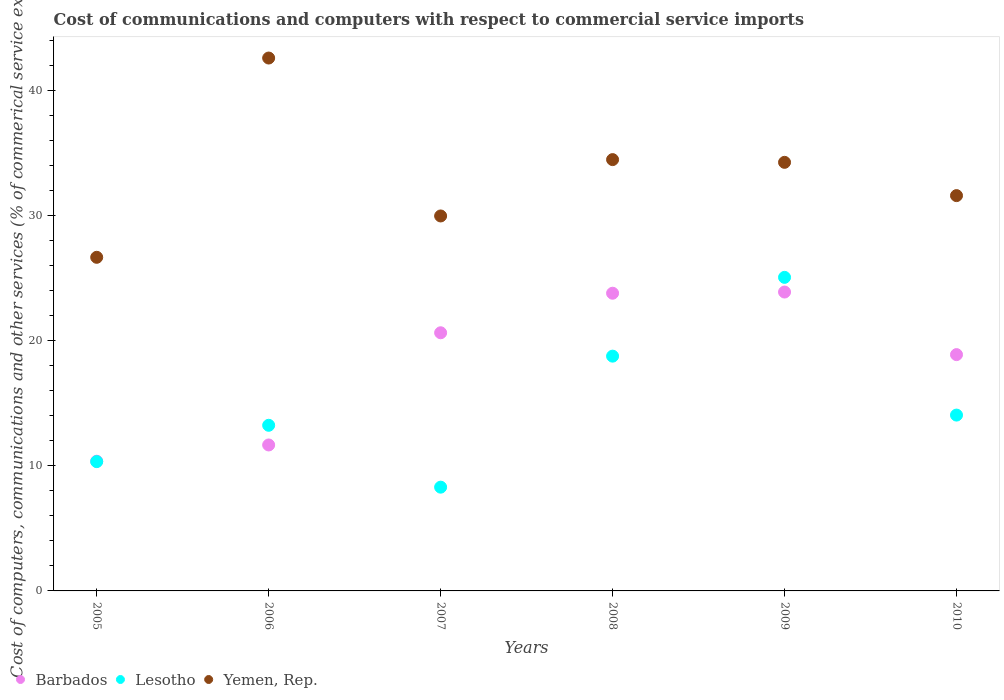Is the number of dotlines equal to the number of legend labels?
Provide a succinct answer. Yes. What is the cost of communications and computers in Yemen, Rep. in 2007?
Offer a very short reply. 29.97. Across all years, what is the maximum cost of communications and computers in Lesotho?
Offer a terse response. 25.06. Across all years, what is the minimum cost of communications and computers in Barbados?
Make the answer very short. 10.37. What is the total cost of communications and computers in Barbados in the graph?
Your answer should be very brief. 109.24. What is the difference between the cost of communications and computers in Yemen, Rep. in 2007 and that in 2008?
Provide a succinct answer. -4.5. What is the difference between the cost of communications and computers in Yemen, Rep. in 2009 and the cost of communications and computers in Barbados in 2008?
Your response must be concise. 10.46. What is the average cost of communications and computers in Lesotho per year?
Ensure brevity in your answer.  14.96. In the year 2009, what is the difference between the cost of communications and computers in Barbados and cost of communications and computers in Lesotho?
Your response must be concise. -1.17. In how many years, is the cost of communications and computers in Yemen, Rep. greater than 18 %?
Ensure brevity in your answer.  6. What is the ratio of the cost of communications and computers in Barbados in 2005 to that in 2010?
Your response must be concise. 0.55. Is the difference between the cost of communications and computers in Barbados in 2009 and 2010 greater than the difference between the cost of communications and computers in Lesotho in 2009 and 2010?
Provide a short and direct response. No. What is the difference between the highest and the second highest cost of communications and computers in Yemen, Rep.?
Provide a succinct answer. 8.12. What is the difference between the highest and the lowest cost of communications and computers in Yemen, Rep.?
Make the answer very short. 15.93. In how many years, is the cost of communications and computers in Barbados greater than the average cost of communications and computers in Barbados taken over all years?
Your answer should be compact. 4. Is the sum of the cost of communications and computers in Barbados in 2007 and 2009 greater than the maximum cost of communications and computers in Yemen, Rep. across all years?
Give a very brief answer. Yes. Is it the case that in every year, the sum of the cost of communications and computers in Yemen, Rep. and cost of communications and computers in Lesotho  is greater than the cost of communications and computers in Barbados?
Offer a terse response. Yes. Is the cost of communications and computers in Barbados strictly greater than the cost of communications and computers in Lesotho over the years?
Make the answer very short. No. How many dotlines are there?
Give a very brief answer. 3. How many years are there in the graph?
Keep it short and to the point. 6. What is the difference between two consecutive major ticks on the Y-axis?
Make the answer very short. 10. Are the values on the major ticks of Y-axis written in scientific E-notation?
Make the answer very short. No. Does the graph contain any zero values?
Your response must be concise. No. Does the graph contain grids?
Provide a succinct answer. No. What is the title of the graph?
Offer a very short reply. Cost of communications and computers with respect to commercial service imports. Does "Faeroe Islands" appear as one of the legend labels in the graph?
Your response must be concise. No. What is the label or title of the X-axis?
Ensure brevity in your answer.  Years. What is the label or title of the Y-axis?
Keep it short and to the point. Cost of computers, communications and other services (% of commerical service exports). What is the Cost of computers, communications and other services (% of commerical service exports) of Barbados in 2005?
Offer a very short reply. 10.37. What is the Cost of computers, communications and other services (% of commerical service exports) of Lesotho in 2005?
Your response must be concise. 10.33. What is the Cost of computers, communications and other services (% of commerical service exports) of Yemen, Rep. in 2005?
Make the answer very short. 26.67. What is the Cost of computers, communications and other services (% of commerical service exports) of Barbados in 2006?
Provide a succinct answer. 11.67. What is the Cost of computers, communications and other services (% of commerical service exports) of Lesotho in 2006?
Give a very brief answer. 13.24. What is the Cost of computers, communications and other services (% of commerical service exports) in Yemen, Rep. in 2006?
Provide a succinct answer. 42.59. What is the Cost of computers, communications and other services (% of commerical service exports) of Barbados in 2007?
Ensure brevity in your answer.  20.63. What is the Cost of computers, communications and other services (% of commerical service exports) of Lesotho in 2007?
Give a very brief answer. 8.29. What is the Cost of computers, communications and other services (% of commerical service exports) in Yemen, Rep. in 2007?
Provide a succinct answer. 29.97. What is the Cost of computers, communications and other services (% of commerical service exports) of Barbados in 2008?
Your answer should be compact. 23.79. What is the Cost of computers, communications and other services (% of commerical service exports) of Lesotho in 2008?
Provide a short and direct response. 18.77. What is the Cost of computers, communications and other services (% of commerical service exports) of Yemen, Rep. in 2008?
Offer a very short reply. 34.47. What is the Cost of computers, communications and other services (% of commerical service exports) of Barbados in 2009?
Provide a succinct answer. 23.89. What is the Cost of computers, communications and other services (% of commerical service exports) in Lesotho in 2009?
Offer a terse response. 25.06. What is the Cost of computers, communications and other services (% of commerical service exports) in Yemen, Rep. in 2009?
Offer a very short reply. 34.26. What is the Cost of computers, communications and other services (% of commerical service exports) in Barbados in 2010?
Keep it short and to the point. 18.89. What is the Cost of computers, communications and other services (% of commerical service exports) of Lesotho in 2010?
Keep it short and to the point. 14.05. What is the Cost of computers, communications and other services (% of commerical service exports) of Yemen, Rep. in 2010?
Give a very brief answer. 31.6. Across all years, what is the maximum Cost of computers, communications and other services (% of commerical service exports) in Barbados?
Offer a very short reply. 23.89. Across all years, what is the maximum Cost of computers, communications and other services (% of commerical service exports) in Lesotho?
Make the answer very short. 25.06. Across all years, what is the maximum Cost of computers, communications and other services (% of commerical service exports) of Yemen, Rep.?
Keep it short and to the point. 42.59. Across all years, what is the minimum Cost of computers, communications and other services (% of commerical service exports) of Barbados?
Keep it short and to the point. 10.37. Across all years, what is the minimum Cost of computers, communications and other services (% of commerical service exports) in Lesotho?
Keep it short and to the point. 8.29. Across all years, what is the minimum Cost of computers, communications and other services (% of commerical service exports) in Yemen, Rep.?
Your response must be concise. 26.67. What is the total Cost of computers, communications and other services (% of commerical service exports) of Barbados in the graph?
Provide a short and direct response. 109.24. What is the total Cost of computers, communications and other services (% of commerical service exports) of Lesotho in the graph?
Give a very brief answer. 89.75. What is the total Cost of computers, communications and other services (% of commerical service exports) of Yemen, Rep. in the graph?
Keep it short and to the point. 199.56. What is the difference between the Cost of computers, communications and other services (% of commerical service exports) of Barbados in 2005 and that in 2006?
Provide a succinct answer. -1.3. What is the difference between the Cost of computers, communications and other services (% of commerical service exports) of Lesotho in 2005 and that in 2006?
Provide a succinct answer. -2.9. What is the difference between the Cost of computers, communications and other services (% of commerical service exports) of Yemen, Rep. in 2005 and that in 2006?
Ensure brevity in your answer.  -15.93. What is the difference between the Cost of computers, communications and other services (% of commerical service exports) of Barbados in 2005 and that in 2007?
Offer a very short reply. -10.27. What is the difference between the Cost of computers, communications and other services (% of commerical service exports) in Lesotho in 2005 and that in 2007?
Your answer should be compact. 2.04. What is the difference between the Cost of computers, communications and other services (% of commerical service exports) of Yemen, Rep. in 2005 and that in 2007?
Offer a very short reply. -3.3. What is the difference between the Cost of computers, communications and other services (% of commerical service exports) in Barbados in 2005 and that in 2008?
Your response must be concise. -13.43. What is the difference between the Cost of computers, communications and other services (% of commerical service exports) in Lesotho in 2005 and that in 2008?
Your response must be concise. -8.43. What is the difference between the Cost of computers, communications and other services (% of commerical service exports) of Yemen, Rep. in 2005 and that in 2008?
Make the answer very short. -7.81. What is the difference between the Cost of computers, communications and other services (% of commerical service exports) of Barbados in 2005 and that in 2009?
Offer a very short reply. -13.52. What is the difference between the Cost of computers, communications and other services (% of commerical service exports) of Lesotho in 2005 and that in 2009?
Provide a short and direct response. -14.73. What is the difference between the Cost of computers, communications and other services (% of commerical service exports) in Yemen, Rep. in 2005 and that in 2009?
Your answer should be compact. -7.59. What is the difference between the Cost of computers, communications and other services (% of commerical service exports) of Barbados in 2005 and that in 2010?
Your answer should be very brief. -8.52. What is the difference between the Cost of computers, communications and other services (% of commerical service exports) of Lesotho in 2005 and that in 2010?
Provide a succinct answer. -3.72. What is the difference between the Cost of computers, communications and other services (% of commerical service exports) of Yemen, Rep. in 2005 and that in 2010?
Provide a succinct answer. -4.93. What is the difference between the Cost of computers, communications and other services (% of commerical service exports) of Barbados in 2006 and that in 2007?
Provide a succinct answer. -8.97. What is the difference between the Cost of computers, communications and other services (% of commerical service exports) in Lesotho in 2006 and that in 2007?
Your answer should be compact. 4.95. What is the difference between the Cost of computers, communications and other services (% of commerical service exports) in Yemen, Rep. in 2006 and that in 2007?
Your response must be concise. 12.62. What is the difference between the Cost of computers, communications and other services (% of commerical service exports) of Barbados in 2006 and that in 2008?
Ensure brevity in your answer.  -12.13. What is the difference between the Cost of computers, communications and other services (% of commerical service exports) of Lesotho in 2006 and that in 2008?
Provide a succinct answer. -5.53. What is the difference between the Cost of computers, communications and other services (% of commerical service exports) in Yemen, Rep. in 2006 and that in 2008?
Keep it short and to the point. 8.12. What is the difference between the Cost of computers, communications and other services (% of commerical service exports) in Barbados in 2006 and that in 2009?
Make the answer very short. -12.22. What is the difference between the Cost of computers, communications and other services (% of commerical service exports) in Lesotho in 2006 and that in 2009?
Your answer should be very brief. -11.82. What is the difference between the Cost of computers, communications and other services (% of commerical service exports) of Yemen, Rep. in 2006 and that in 2009?
Your response must be concise. 8.34. What is the difference between the Cost of computers, communications and other services (% of commerical service exports) in Barbados in 2006 and that in 2010?
Keep it short and to the point. -7.22. What is the difference between the Cost of computers, communications and other services (% of commerical service exports) of Lesotho in 2006 and that in 2010?
Give a very brief answer. -0.82. What is the difference between the Cost of computers, communications and other services (% of commerical service exports) in Yemen, Rep. in 2006 and that in 2010?
Your answer should be very brief. 11. What is the difference between the Cost of computers, communications and other services (% of commerical service exports) of Barbados in 2007 and that in 2008?
Your answer should be compact. -3.16. What is the difference between the Cost of computers, communications and other services (% of commerical service exports) in Lesotho in 2007 and that in 2008?
Keep it short and to the point. -10.47. What is the difference between the Cost of computers, communications and other services (% of commerical service exports) of Yemen, Rep. in 2007 and that in 2008?
Offer a very short reply. -4.5. What is the difference between the Cost of computers, communications and other services (% of commerical service exports) in Barbados in 2007 and that in 2009?
Your answer should be compact. -3.26. What is the difference between the Cost of computers, communications and other services (% of commerical service exports) of Lesotho in 2007 and that in 2009?
Your answer should be very brief. -16.77. What is the difference between the Cost of computers, communications and other services (% of commerical service exports) of Yemen, Rep. in 2007 and that in 2009?
Offer a terse response. -4.29. What is the difference between the Cost of computers, communications and other services (% of commerical service exports) of Barbados in 2007 and that in 2010?
Make the answer very short. 1.75. What is the difference between the Cost of computers, communications and other services (% of commerical service exports) in Lesotho in 2007 and that in 2010?
Ensure brevity in your answer.  -5.76. What is the difference between the Cost of computers, communications and other services (% of commerical service exports) in Yemen, Rep. in 2007 and that in 2010?
Your response must be concise. -1.63. What is the difference between the Cost of computers, communications and other services (% of commerical service exports) in Barbados in 2008 and that in 2009?
Give a very brief answer. -0.1. What is the difference between the Cost of computers, communications and other services (% of commerical service exports) in Lesotho in 2008 and that in 2009?
Offer a very short reply. -6.3. What is the difference between the Cost of computers, communications and other services (% of commerical service exports) in Yemen, Rep. in 2008 and that in 2009?
Your answer should be compact. 0.22. What is the difference between the Cost of computers, communications and other services (% of commerical service exports) of Barbados in 2008 and that in 2010?
Give a very brief answer. 4.91. What is the difference between the Cost of computers, communications and other services (% of commerical service exports) of Lesotho in 2008 and that in 2010?
Provide a succinct answer. 4.71. What is the difference between the Cost of computers, communications and other services (% of commerical service exports) of Yemen, Rep. in 2008 and that in 2010?
Your answer should be compact. 2.88. What is the difference between the Cost of computers, communications and other services (% of commerical service exports) of Barbados in 2009 and that in 2010?
Provide a short and direct response. 5. What is the difference between the Cost of computers, communications and other services (% of commerical service exports) in Lesotho in 2009 and that in 2010?
Your response must be concise. 11.01. What is the difference between the Cost of computers, communications and other services (% of commerical service exports) of Yemen, Rep. in 2009 and that in 2010?
Your answer should be compact. 2.66. What is the difference between the Cost of computers, communications and other services (% of commerical service exports) of Barbados in 2005 and the Cost of computers, communications and other services (% of commerical service exports) of Lesotho in 2006?
Give a very brief answer. -2.87. What is the difference between the Cost of computers, communications and other services (% of commerical service exports) of Barbados in 2005 and the Cost of computers, communications and other services (% of commerical service exports) of Yemen, Rep. in 2006?
Keep it short and to the point. -32.23. What is the difference between the Cost of computers, communications and other services (% of commerical service exports) in Lesotho in 2005 and the Cost of computers, communications and other services (% of commerical service exports) in Yemen, Rep. in 2006?
Keep it short and to the point. -32.26. What is the difference between the Cost of computers, communications and other services (% of commerical service exports) in Barbados in 2005 and the Cost of computers, communications and other services (% of commerical service exports) in Lesotho in 2007?
Provide a succinct answer. 2.07. What is the difference between the Cost of computers, communications and other services (% of commerical service exports) in Barbados in 2005 and the Cost of computers, communications and other services (% of commerical service exports) in Yemen, Rep. in 2007?
Ensure brevity in your answer.  -19.6. What is the difference between the Cost of computers, communications and other services (% of commerical service exports) in Lesotho in 2005 and the Cost of computers, communications and other services (% of commerical service exports) in Yemen, Rep. in 2007?
Give a very brief answer. -19.64. What is the difference between the Cost of computers, communications and other services (% of commerical service exports) of Barbados in 2005 and the Cost of computers, communications and other services (% of commerical service exports) of Lesotho in 2008?
Offer a terse response. -8.4. What is the difference between the Cost of computers, communications and other services (% of commerical service exports) of Barbados in 2005 and the Cost of computers, communications and other services (% of commerical service exports) of Yemen, Rep. in 2008?
Your answer should be very brief. -24.11. What is the difference between the Cost of computers, communications and other services (% of commerical service exports) of Lesotho in 2005 and the Cost of computers, communications and other services (% of commerical service exports) of Yemen, Rep. in 2008?
Ensure brevity in your answer.  -24.14. What is the difference between the Cost of computers, communications and other services (% of commerical service exports) of Barbados in 2005 and the Cost of computers, communications and other services (% of commerical service exports) of Lesotho in 2009?
Offer a very short reply. -14.7. What is the difference between the Cost of computers, communications and other services (% of commerical service exports) of Barbados in 2005 and the Cost of computers, communications and other services (% of commerical service exports) of Yemen, Rep. in 2009?
Give a very brief answer. -23.89. What is the difference between the Cost of computers, communications and other services (% of commerical service exports) in Lesotho in 2005 and the Cost of computers, communications and other services (% of commerical service exports) in Yemen, Rep. in 2009?
Provide a succinct answer. -23.92. What is the difference between the Cost of computers, communications and other services (% of commerical service exports) in Barbados in 2005 and the Cost of computers, communications and other services (% of commerical service exports) in Lesotho in 2010?
Your answer should be compact. -3.69. What is the difference between the Cost of computers, communications and other services (% of commerical service exports) in Barbados in 2005 and the Cost of computers, communications and other services (% of commerical service exports) in Yemen, Rep. in 2010?
Your answer should be compact. -21.23. What is the difference between the Cost of computers, communications and other services (% of commerical service exports) in Lesotho in 2005 and the Cost of computers, communications and other services (% of commerical service exports) in Yemen, Rep. in 2010?
Keep it short and to the point. -21.26. What is the difference between the Cost of computers, communications and other services (% of commerical service exports) in Barbados in 2006 and the Cost of computers, communications and other services (% of commerical service exports) in Lesotho in 2007?
Provide a short and direct response. 3.37. What is the difference between the Cost of computers, communications and other services (% of commerical service exports) of Barbados in 2006 and the Cost of computers, communications and other services (% of commerical service exports) of Yemen, Rep. in 2007?
Your answer should be compact. -18.3. What is the difference between the Cost of computers, communications and other services (% of commerical service exports) in Lesotho in 2006 and the Cost of computers, communications and other services (% of commerical service exports) in Yemen, Rep. in 2007?
Provide a short and direct response. -16.73. What is the difference between the Cost of computers, communications and other services (% of commerical service exports) in Barbados in 2006 and the Cost of computers, communications and other services (% of commerical service exports) in Lesotho in 2008?
Your answer should be compact. -7.1. What is the difference between the Cost of computers, communications and other services (% of commerical service exports) in Barbados in 2006 and the Cost of computers, communications and other services (% of commerical service exports) in Yemen, Rep. in 2008?
Offer a very short reply. -22.81. What is the difference between the Cost of computers, communications and other services (% of commerical service exports) in Lesotho in 2006 and the Cost of computers, communications and other services (% of commerical service exports) in Yemen, Rep. in 2008?
Provide a succinct answer. -21.24. What is the difference between the Cost of computers, communications and other services (% of commerical service exports) in Barbados in 2006 and the Cost of computers, communications and other services (% of commerical service exports) in Lesotho in 2009?
Offer a very short reply. -13.4. What is the difference between the Cost of computers, communications and other services (% of commerical service exports) of Barbados in 2006 and the Cost of computers, communications and other services (% of commerical service exports) of Yemen, Rep. in 2009?
Offer a terse response. -22.59. What is the difference between the Cost of computers, communications and other services (% of commerical service exports) of Lesotho in 2006 and the Cost of computers, communications and other services (% of commerical service exports) of Yemen, Rep. in 2009?
Provide a succinct answer. -21.02. What is the difference between the Cost of computers, communications and other services (% of commerical service exports) in Barbados in 2006 and the Cost of computers, communications and other services (% of commerical service exports) in Lesotho in 2010?
Make the answer very short. -2.39. What is the difference between the Cost of computers, communications and other services (% of commerical service exports) in Barbados in 2006 and the Cost of computers, communications and other services (% of commerical service exports) in Yemen, Rep. in 2010?
Make the answer very short. -19.93. What is the difference between the Cost of computers, communications and other services (% of commerical service exports) in Lesotho in 2006 and the Cost of computers, communications and other services (% of commerical service exports) in Yemen, Rep. in 2010?
Offer a terse response. -18.36. What is the difference between the Cost of computers, communications and other services (% of commerical service exports) in Barbados in 2007 and the Cost of computers, communications and other services (% of commerical service exports) in Lesotho in 2008?
Your response must be concise. 1.87. What is the difference between the Cost of computers, communications and other services (% of commerical service exports) in Barbados in 2007 and the Cost of computers, communications and other services (% of commerical service exports) in Yemen, Rep. in 2008?
Ensure brevity in your answer.  -13.84. What is the difference between the Cost of computers, communications and other services (% of commerical service exports) in Lesotho in 2007 and the Cost of computers, communications and other services (% of commerical service exports) in Yemen, Rep. in 2008?
Make the answer very short. -26.18. What is the difference between the Cost of computers, communications and other services (% of commerical service exports) of Barbados in 2007 and the Cost of computers, communications and other services (% of commerical service exports) of Lesotho in 2009?
Your response must be concise. -4.43. What is the difference between the Cost of computers, communications and other services (% of commerical service exports) of Barbados in 2007 and the Cost of computers, communications and other services (% of commerical service exports) of Yemen, Rep. in 2009?
Your answer should be very brief. -13.62. What is the difference between the Cost of computers, communications and other services (% of commerical service exports) of Lesotho in 2007 and the Cost of computers, communications and other services (% of commerical service exports) of Yemen, Rep. in 2009?
Provide a short and direct response. -25.96. What is the difference between the Cost of computers, communications and other services (% of commerical service exports) of Barbados in 2007 and the Cost of computers, communications and other services (% of commerical service exports) of Lesotho in 2010?
Your answer should be compact. 6.58. What is the difference between the Cost of computers, communications and other services (% of commerical service exports) in Barbados in 2007 and the Cost of computers, communications and other services (% of commerical service exports) in Yemen, Rep. in 2010?
Your answer should be very brief. -10.96. What is the difference between the Cost of computers, communications and other services (% of commerical service exports) of Lesotho in 2007 and the Cost of computers, communications and other services (% of commerical service exports) of Yemen, Rep. in 2010?
Your answer should be very brief. -23.3. What is the difference between the Cost of computers, communications and other services (% of commerical service exports) in Barbados in 2008 and the Cost of computers, communications and other services (% of commerical service exports) in Lesotho in 2009?
Keep it short and to the point. -1.27. What is the difference between the Cost of computers, communications and other services (% of commerical service exports) in Barbados in 2008 and the Cost of computers, communications and other services (% of commerical service exports) in Yemen, Rep. in 2009?
Keep it short and to the point. -10.46. What is the difference between the Cost of computers, communications and other services (% of commerical service exports) of Lesotho in 2008 and the Cost of computers, communications and other services (% of commerical service exports) of Yemen, Rep. in 2009?
Offer a terse response. -15.49. What is the difference between the Cost of computers, communications and other services (% of commerical service exports) of Barbados in 2008 and the Cost of computers, communications and other services (% of commerical service exports) of Lesotho in 2010?
Provide a succinct answer. 9.74. What is the difference between the Cost of computers, communications and other services (% of commerical service exports) of Barbados in 2008 and the Cost of computers, communications and other services (% of commerical service exports) of Yemen, Rep. in 2010?
Offer a very short reply. -7.8. What is the difference between the Cost of computers, communications and other services (% of commerical service exports) in Lesotho in 2008 and the Cost of computers, communications and other services (% of commerical service exports) in Yemen, Rep. in 2010?
Your answer should be very brief. -12.83. What is the difference between the Cost of computers, communications and other services (% of commerical service exports) of Barbados in 2009 and the Cost of computers, communications and other services (% of commerical service exports) of Lesotho in 2010?
Offer a terse response. 9.84. What is the difference between the Cost of computers, communications and other services (% of commerical service exports) in Barbados in 2009 and the Cost of computers, communications and other services (% of commerical service exports) in Yemen, Rep. in 2010?
Give a very brief answer. -7.71. What is the difference between the Cost of computers, communications and other services (% of commerical service exports) in Lesotho in 2009 and the Cost of computers, communications and other services (% of commerical service exports) in Yemen, Rep. in 2010?
Offer a terse response. -6.53. What is the average Cost of computers, communications and other services (% of commerical service exports) of Barbados per year?
Provide a succinct answer. 18.21. What is the average Cost of computers, communications and other services (% of commerical service exports) in Lesotho per year?
Provide a short and direct response. 14.96. What is the average Cost of computers, communications and other services (% of commerical service exports) of Yemen, Rep. per year?
Provide a succinct answer. 33.26. In the year 2005, what is the difference between the Cost of computers, communications and other services (% of commerical service exports) of Barbados and Cost of computers, communications and other services (% of commerical service exports) of Lesotho?
Give a very brief answer. 0.03. In the year 2005, what is the difference between the Cost of computers, communications and other services (% of commerical service exports) of Barbados and Cost of computers, communications and other services (% of commerical service exports) of Yemen, Rep.?
Offer a very short reply. -16.3. In the year 2005, what is the difference between the Cost of computers, communications and other services (% of commerical service exports) in Lesotho and Cost of computers, communications and other services (% of commerical service exports) in Yemen, Rep.?
Offer a terse response. -16.33. In the year 2006, what is the difference between the Cost of computers, communications and other services (% of commerical service exports) in Barbados and Cost of computers, communications and other services (% of commerical service exports) in Lesotho?
Provide a succinct answer. -1.57. In the year 2006, what is the difference between the Cost of computers, communications and other services (% of commerical service exports) of Barbados and Cost of computers, communications and other services (% of commerical service exports) of Yemen, Rep.?
Offer a terse response. -30.93. In the year 2006, what is the difference between the Cost of computers, communications and other services (% of commerical service exports) in Lesotho and Cost of computers, communications and other services (% of commerical service exports) in Yemen, Rep.?
Offer a very short reply. -29.36. In the year 2007, what is the difference between the Cost of computers, communications and other services (% of commerical service exports) of Barbados and Cost of computers, communications and other services (% of commerical service exports) of Lesotho?
Offer a terse response. 12.34. In the year 2007, what is the difference between the Cost of computers, communications and other services (% of commerical service exports) of Barbados and Cost of computers, communications and other services (% of commerical service exports) of Yemen, Rep.?
Provide a succinct answer. -9.34. In the year 2007, what is the difference between the Cost of computers, communications and other services (% of commerical service exports) of Lesotho and Cost of computers, communications and other services (% of commerical service exports) of Yemen, Rep.?
Keep it short and to the point. -21.68. In the year 2008, what is the difference between the Cost of computers, communications and other services (% of commerical service exports) of Barbados and Cost of computers, communications and other services (% of commerical service exports) of Lesotho?
Ensure brevity in your answer.  5.03. In the year 2008, what is the difference between the Cost of computers, communications and other services (% of commerical service exports) of Barbados and Cost of computers, communications and other services (% of commerical service exports) of Yemen, Rep.?
Make the answer very short. -10.68. In the year 2008, what is the difference between the Cost of computers, communications and other services (% of commerical service exports) in Lesotho and Cost of computers, communications and other services (% of commerical service exports) in Yemen, Rep.?
Your answer should be compact. -15.71. In the year 2009, what is the difference between the Cost of computers, communications and other services (% of commerical service exports) in Barbados and Cost of computers, communications and other services (% of commerical service exports) in Lesotho?
Offer a very short reply. -1.17. In the year 2009, what is the difference between the Cost of computers, communications and other services (% of commerical service exports) in Barbados and Cost of computers, communications and other services (% of commerical service exports) in Yemen, Rep.?
Provide a short and direct response. -10.37. In the year 2009, what is the difference between the Cost of computers, communications and other services (% of commerical service exports) in Lesotho and Cost of computers, communications and other services (% of commerical service exports) in Yemen, Rep.?
Provide a succinct answer. -9.19. In the year 2010, what is the difference between the Cost of computers, communications and other services (% of commerical service exports) in Barbados and Cost of computers, communications and other services (% of commerical service exports) in Lesotho?
Offer a terse response. 4.83. In the year 2010, what is the difference between the Cost of computers, communications and other services (% of commerical service exports) of Barbados and Cost of computers, communications and other services (% of commerical service exports) of Yemen, Rep.?
Your response must be concise. -12.71. In the year 2010, what is the difference between the Cost of computers, communications and other services (% of commerical service exports) of Lesotho and Cost of computers, communications and other services (% of commerical service exports) of Yemen, Rep.?
Keep it short and to the point. -17.54. What is the ratio of the Cost of computers, communications and other services (% of commerical service exports) in Barbados in 2005 to that in 2006?
Provide a succinct answer. 0.89. What is the ratio of the Cost of computers, communications and other services (% of commerical service exports) in Lesotho in 2005 to that in 2006?
Your response must be concise. 0.78. What is the ratio of the Cost of computers, communications and other services (% of commerical service exports) in Yemen, Rep. in 2005 to that in 2006?
Give a very brief answer. 0.63. What is the ratio of the Cost of computers, communications and other services (% of commerical service exports) of Barbados in 2005 to that in 2007?
Offer a terse response. 0.5. What is the ratio of the Cost of computers, communications and other services (% of commerical service exports) in Lesotho in 2005 to that in 2007?
Ensure brevity in your answer.  1.25. What is the ratio of the Cost of computers, communications and other services (% of commerical service exports) in Yemen, Rep. in 2005 to that in 2007?
Your answer should be very brief. 0.89. What is the ratio of the Cost of computers, communications and other services (% of commerical service exports) in Barbados in 2005 to that in 2008?
Your response must be concise. 0.44. What is the ratio of the Cost of computers, communications and other services (% of commerical service exports) of Lesotho in 2005 to that in 2008?
Offer a terse response. 0.55. What is the ratio of the Cost of computers, communications and other services (% of commerical service exports) in Yemen, Rep. in 2005 to that in 2008?
Your response must be concise. 0.77. What is the ratio of the Cost of computers, communications and other services (% of commerical service exports) of Barbados in 2005 to that in 2009?
Offer a very short reply. 0.43. What is the ratio of the Cost of computers, communications and other services (% of commerical service exports) of Lesotho in 2005 to that in 2009?
Provide a short and direct response. 0.41. What is the ratio of the Cost of computers, communications and other services (% of commerical service exports) in Yemen, Rep. in 2005 to that in 2009?
Provide a short and direct response. 0.78. What is the ratio of the Cost of computers, communications and other services (% of commerical service exports) of Barbados in 2005 to that in 2010?
Your answer should be compact. 0.55. What is the ratio of the Cost of computers, communications and other services (% of commerical service exports) of Lesotho in 2005 to that in 2010?
Make the answer very short. 0.74. What is the ratio of the Cost of computers, communications and other services (% of commerical service exports) of Yemen, Rep. in 2005 to that in 2010?
Keep it short and to the point. 0.84. What is the ratio of the Cost of computers, communications and other services (% of commerical service exports) in Barbados in 2006 to that in 2007?
Provide a succinct answer. 0.57. What is the ratio of the Cost of computers, communications and other services (% of commerical service exports) in Lesotho in 2006 to that in 2007?
Give a very brief answer. 1.6. What is the ratio of the Cost of computers, communications and other services (% of commerical service exports) in Yemen, Rep. in 2006 to that in 2007?
Your answer should be compact. 1.42. What is the ratio of the Cost of computers, communications and other services (% of commerical service exports) in Barbados in 2006 to that in 2008?
Make the answer very short. 0.49. What is the ratio of the Cost of computers, communications and other services (% of commerical service exports) in Lesotho in 2006 to that in 2008?
Make the answer very short. 0.71. What is the ratio of the Cost of computers, communications and other services (% of commerical service exports) in Yemen, Rep. in 2006 to that in 2008?
Your answer should be very brief. 1.24. What is the ratio of the Cost of computers, communications and other services (% of commerical service exports) of Barbados in 2006 to that in 2009?
Offer a terse response. 0.49. What is the ratio of the Cost of computers, communications and other services (% of commerical service exports) of Lesotho in 2006 to that in 2009?
Your answer should be very brief. 0.53. What is the ratio of the Cost of computers, communications and other services (% of commerical service exports) of Yemen, Rep. in 2006 to that in 2009?
Offer a very short reply. 1.24. What is the ratio of the Cost of computers, communications and other services (% of commerical service exports) of Barbados in 2006 to that in 2010?
Ensure brevity in your answer.  0.62. What is the ratio of the Cost of computers, communications and other services (% of commerical service exports) of Lesotho in 2006 to that in 2010?
Provide a succinct answer. 0.94. What is the ratio of the Cost of computers, communications and other services (% of commerical service exports) in Yemen, Rep. in 2006 to that in 2010?
Your answer should be compact. 1.35. What is the ratio of the Cost of computers, communications and other services (% of commerical service exports) in Barbados in 2007 to that in 2008?
Provide a succinct answer. 0.87. What is the ratio of the Cost of computers, communications and other services (% of commerical service exports) of Lesotho in 2007 to that in 2008?
Offer a very short reply. 0.44. What is the ratio of the Cost of computers, communications and other services (% of commerical service exports) in Yemen, Rep. in 2007 to that in 2008?
Make the answer very short. 0.87. What is the ratio of the Cost of computers, communications and other services (% of commerical service exports) of Barbados in 2007 to that in 2009?
Provide a short and direct response. 0.86. What is the ratio of the Cost of computers, communications and other services (% of commerical service exports) of Lesotho in 2007 to that in 2009?
Your answer should be compact. 0.33. What is the ratio of the Cost of computers, communications and other services (% of commerical service exports) of Yemen, Rep. in 2007 to that in 2009?
Your response must be concise. 0.87. What is the ratio of the Cost of computers, communications and other services (% of commerical service exports) in Barbados in 2007 to that in 2010?
Your response must be concise. 1.09. What is the ratio of the Cost of computers, communications and other services (% of commerical service exports) in Lesotho in 2007 to that in 2010?
Provide a short and direct response. 0.59. What is the ratio of the Cost of computers, communications and other services (% of commerical service exports) in Yemen, Rep. in 2007 to that in 2010?
Offer a very short reply. 0.95. What is the ratio of the Cost of computers, communications and other services (% of commerical service exports) of Barbados in 2008 to that in 2009?
Ensure brevity in your answer.  1. What is the ratio of the Cost of computers, communications and other services (% of commerical service exports) of Lesotho in 2008 to that in 2009?
Your response must be concise. 0.75. What is the ratio of the Cost of computers, communications and other services (% of commerical service exports) in Yemen, Rep. in 2008 to that in 2009?
Give a very brief answer. 1.01. What is the ratio of the Cost of computers, communications and other services (% of commerical service exports) of Barbados in 2008 to that in 2010?
Provide a succinct answer. 1.26. What is the ratio of the Cost of computers, communications and other services (% of commerical service exports) of Lesotho in 2008 to that in 2010?
Offer a terse response. 1.34. What is the ratio of the Cost of computers, communications and other services (% of commerical service exports) of Yemen, Rep. in 2008 to that in 2010?
Keep it short and to the point. 1.09. What is the ratio of the Cost of computers, communications and other services (% of commerical service exports) of Barbados in 2009 to that in 2010?
Your answer should be compact. 1.26. What is the ratio of the Cost of computers, communications and other services (% of commerical service exports) of Lesotho in 2009 to that in 2010?
Your response must be concise. 1.78. What is the ratio of the Cost of computers, communications and other services (% of commerical service exports) in Yemen, Rep. in 2009 to that in 2010?
Ensure brevity in your answer.  1.08. What is the difference between the highest and the second highest Cost of computers, communications and other services (% of commerical service exports) in Barbados?
Offer a terse response. 0.1. What is the difference between the highest and the second highest Cost of computers, communications and other services (% of commerical service exports) of Lesotho?
Give a very brief answer. 6.3. What is the difference between the highest and the second highest Cost of computers, communications and other services (% of commerical service exports) of Yemen, Rep.?
Your answer should be compact. 8.12. What is the difference between the highest and the lowest Cost of computers, communications and other services (% of commerical service exports) in Barbados?
Provide a succinct answer. 13.52. What is the difference between the highest and the lowest Cost of computers, communications and other services (% of commerical service exports) of Lesotho?
Provide a short and direct response. 16.77. What is the difference between the highest and the lowest Cost of computers, communications and other services (% of commerical service exports) of Yemen, Rep.?
Keep it short and to the point. 15.93. 